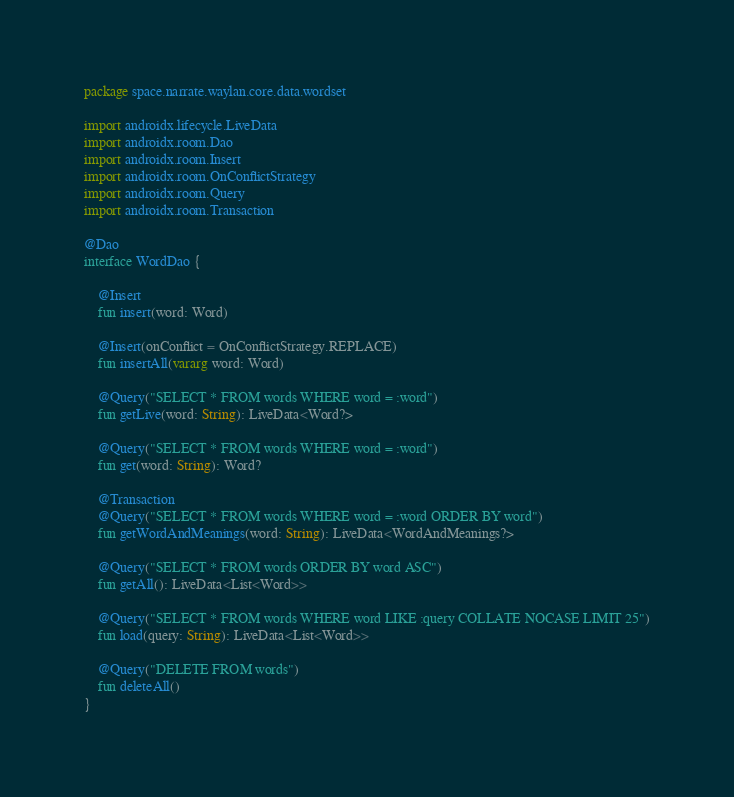Convert code to text. <code><loc_0><loc_0><loc_500><loc_500><_Kotlin_>package space.narrate.waylan.core.data.wordset

import androidx.lifecycle.LiveData
import androidx.room.Dao
import androidx.room.Insert
import androidx.room.OnConflictStrategy
import androidx.room.Query
import androidx.room.Transaction

@Dao
interface WordDao {

    @Insert
    fun insert(word: Word)

    @Insert(onConflict = OnConflictStrategy.REPLACE)
    fun insertAll(vararg word: Word)

    @Query("SELECT * FROM words WHERE word = :word")
    fun getLive(word: String): LiveData<Word?>

    @Query("SELECT * FROM words WHERE word = :word")
    fun get(word: String): Word?

    @Transaction
    @Query("SELECT * FROM words WHERE word = :word ORDER BY word")
    fun getWordAndMeanings(word: String): LiveData<WordAndMeanings?>

    @Query("SELECT * FROM words ORDER BY word ASC")
    fun getAll(): LiveData<List<Word>>

    @Query("SELECT * FROM words WHERE word LIKE :query COLLATE NOCASE LIMIT 25")
    fun load(query: String): LiveData<List<Word>>

    @Query("DELETE FROM words")
    fun deleteAll()
}

</code> 